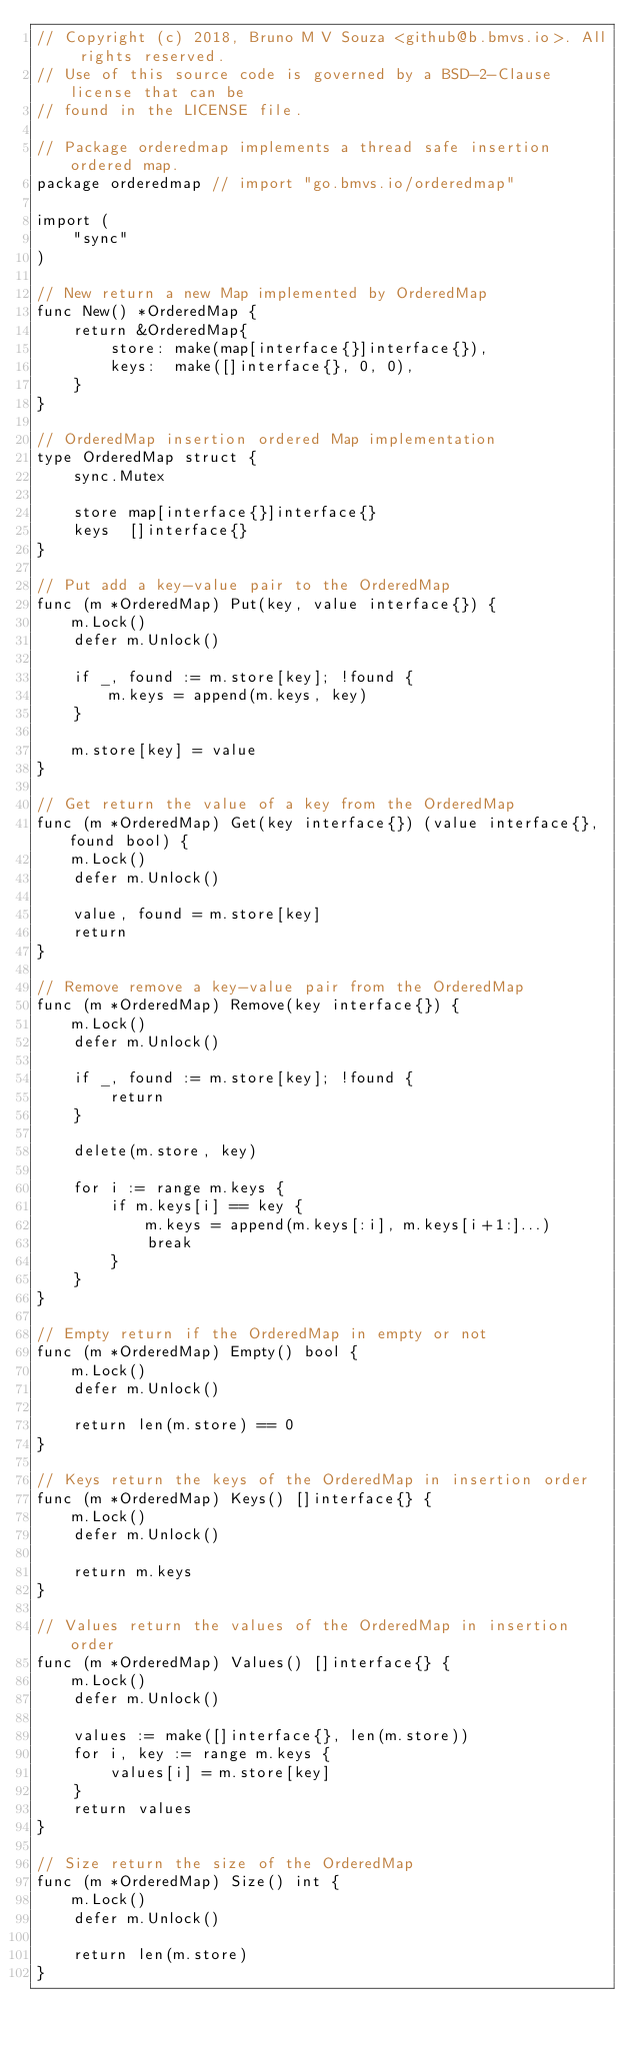Convert code to text. <code><loc_0><loc_0><loc_500><loc_500><_Go_>// Copyright (c) 2018, Bruno M V Souza <github@b.bmvs.io>. All rights reserved.
// Use of this source code is governed by a BSD-2-Clause license that can be
// found in the LICENSE file.

// Package orderedmap implements a thread safe insertion ordered map.
package orderedmap // import "go.bmvs.io/orderedmap"

import (
	"sync"
)

// New return a new Map implemented by OrderedMap
func New() *OrderedMap {
	return &OrderedMap{
		store: make(map[interface{}]interface{}),
		keys:  make([]interface{}, 0, 0),
	}
}

// OrderedMap insertion ordered Map implementation
type OrderedMap struct {
	sync.Mutex

	store map[interface{}]interface{}
	keys  []interface{}
}

// Put add a key-value pair to the OrderedMap
func (m *OrderedMap) Put(key, value interface{}) {
	m.Lock()
	defer m.Unlock()

	if _, found := m.store[key]; !found {
		m.keys = append(m.keys, key)
	}

	m.store[key] = value
}

// Get return the value of a key from the OrderedMap
func (m *OrderedMap) Get(key interface{}) (value interface{}, found bool) {
	m.Lock()
	defer m.Unlock()

	value, found = m.store[key]
	return
}

// Remove remove a key-value pair from the OrderedMap
func (m *OrderedMap) Remove(key interface{}) {
	m.Lock()
	defer m.Unlock()

	if _, found := m.store[key]; !found {
		return
	}

	delete(m.store, key)

	for i := range m.keys {
		if m.keys[i] == key {
			m.keys = append(m.keys[:i], m.keys[i+1:]...)
			break
		}
	}
}

// Empty return if the OrderedMap in empty or not
func (m *OrderedMap) Empty() bool {
	m.Lock()
	defer m.Unlock()

	return len(m.store) == 0
}

// Keys return the keys of the OrderedMap in insertion order
func (m *OrderedMap) Keys() []interface{} {
	m.Lock()
	defer m.Unlock()

	return m.keys
}

// Values return the values of the OrderedMap in insertion order
func (m *OrderedMap) Values() []interface{} {
	m.Lock()
	defer m.Unlock()

	values := make([]interface{}, len(m.store))
	for i, key := range m.keys {
		values[i] = m.store[key]
	}
	return values
}

// Size return the size of the OrderedMap
func (m *OrderedMap) Size() int {
	m.Lock()
	defer m.Unlock()

	return len(m.store)
}
</code> 